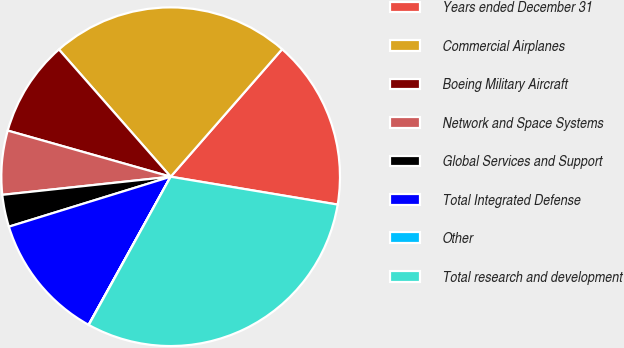Convert chart to OTSL. <chart><loc_0><loc_0><loc_500><loc_500><pie_chart><fcel>Years ended December 31<fcel>Commercial Airplanes<fcel>Boeing Military Aircraft<fcel>Network and Space Systems<fcel>Global Services and Support<fcel>Total Integrated Defense<fcel>Other<fcel>Total research and development<nl><fcel>16.2%<fcel>22.9%<fcel>9.14%<fcel>6.1%<fcel>3.06%<fcel>12.18%<fcel>0.02%<fcel>30.4%<nl></chart> 